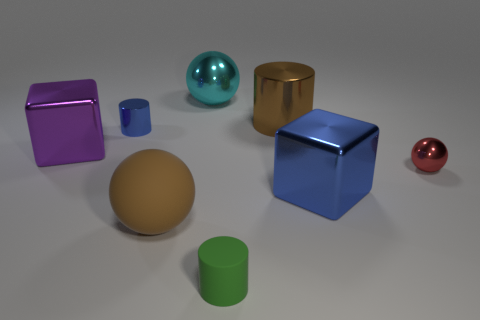Does the large brown object to the right of the big cyan shiny sphere have the same shape as the blue metallic thing in front of the small blue shiny object?
Ensure brevity in your answer.  No. How many cubes are brown metallic objects or metallic objects?
Provide a short and direct response. 2. There is a purple block in front of the blue object that is behind the cube that is on the left side of the big blue shiny cube; what is its material?
Keep it short and to the point. Metal. How many other objects are there of the same size as the blue metal cube?
Provide a succinct answer. 4. Is the number of blue blocks that are in front of the brown ball greater than the number of brown metal cylinders?
Offer a very short reply. No. Is there a thing that has the same color as the small metallic cylinder?
Keep it short and to the point. Yes. There is another sphere that is the same size as the cyan shiny sphere; what color is it?
Keep it short and to the point. Brown. There is a large purple cube in front of the blue cylinder; what number of blue things are in front of it?
Offer a terse response. 1. How many objects are either big metallic objects in front of the large purple block or spheres?
Offer a very short reply. 4. How many green objects have the same material as the red ball?
Ensure brevity in your answer.  0. 